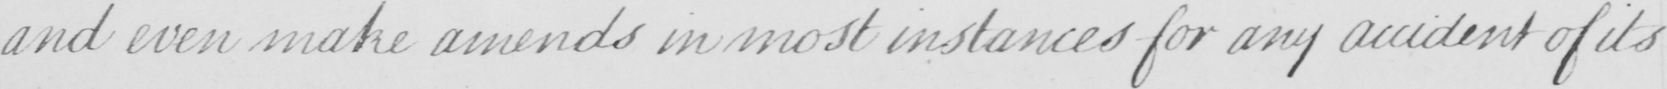What text is written in this handwritten line? and even make amends in most instances for any accident of its 